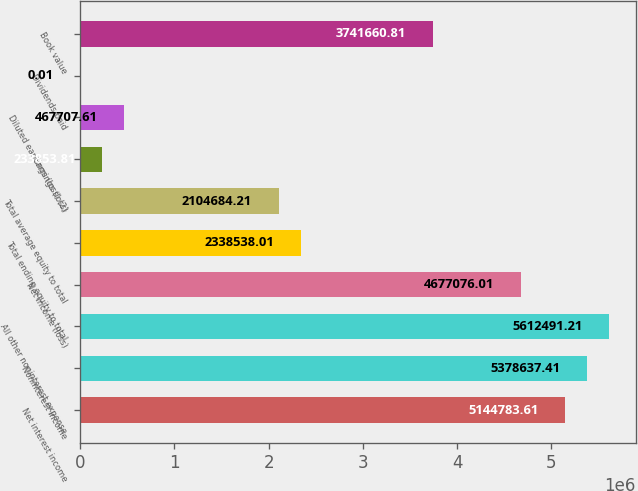Convert chart to OTSL. <chart><loc_0><loc_0><loc_500><loc_500><bar_chart><fcel>Net interest income<fcel>Noninterest income<fcel>All other noninterest expense<fcel>Net income (loss)<fcel>Total ending equity to total<fcel>Total average equity to total<fcel>Earnings (loss)<fcel>Diluted earnings (loss) (2)<fcel>Dividends paid<fcel>Book value<nl><fcel>5.14478e+06<fcel>5.37864e+06<fcel>5.61249e+06<fcel>4.67708e+06<fcel>2.33854e+06<fcel>2.10468e+06<fcel>233854<fcel>467708<fcel>0.01<fcel>3.74166e+06<nl></chart> 